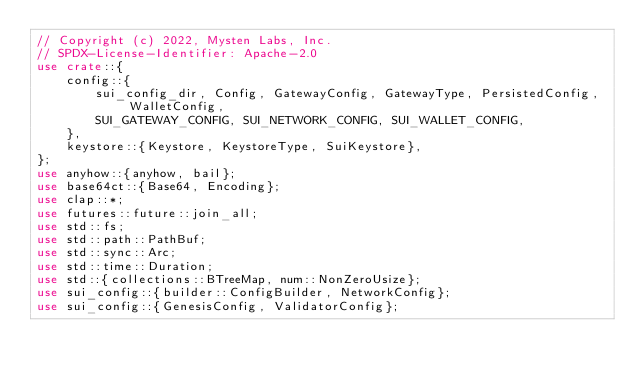<code> <loc_0><loc_0><loc_500><loc_500><_Rust_>// Copyright (c) 2022, Mysten Labs, Inc.
// SPDX-License-Identifier: Apache-2.0
use crate::{
    config::{
        sui_config_dir, Config, GatewayConfig, GatewayType, PersistedConfig, WalletConfig,
        SUI_GATEWAY_CONFIG, SUI_NETWORK_CONFIG, SUI_WALLET_CONFIG,
    },
    keystore::{Keystore, KeystoreType, SuiKeystore},
};
use anyhow::{anyhow, bail};
use base64ct::{Base64, Encoding};
use clap::*;
use futures::future::join_all;
use std::fs;
use std::path::PathBuf;
use std::sync::Arc;
use std::time::Duration;
use std::{collections::BTreeMap, num::NonZeroUsize};
use sui_config::{builder::ConfigBuilder, NetworkConfig};
use sui_config::{GenesisConfig, ValidatorConfig};</code> 